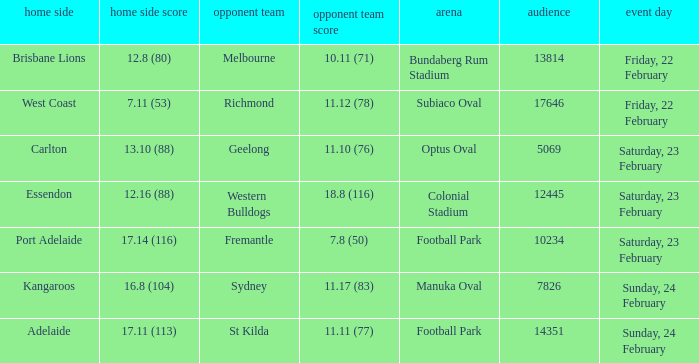On what date did the away team Fremantle play? Saturday, 23 February. 